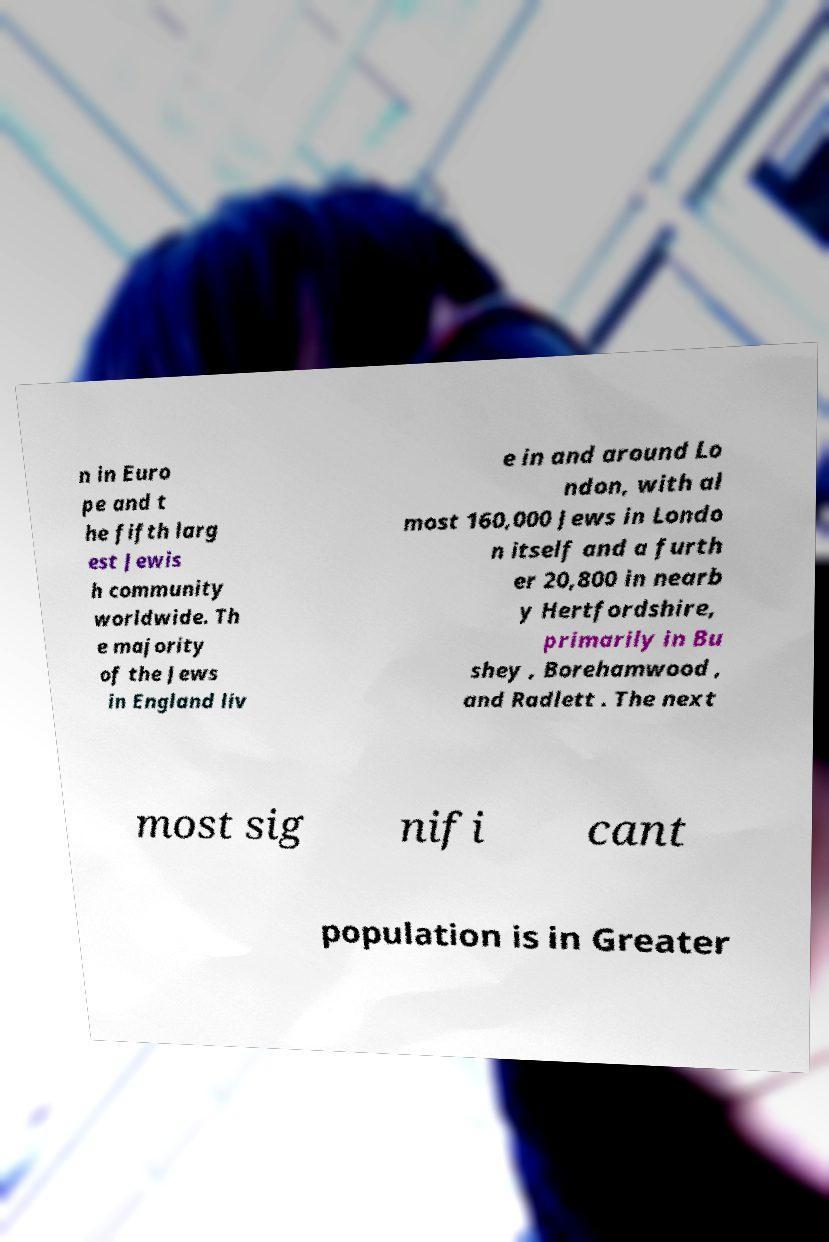Can you accurately transcribe the text from the provided image for me? n in Euro pe and t he fifth larg est Jewis h community worldwide. Th e majority of the Jews in England liv e in and around Lo ndon, with al most 160,000 Jews in Londo n itself and a furth er 20,800 in nearb y Hertfordshire, primarily in Bu shey , Borehamwood , and Radlett . The next most sig nifi cant population is in Greater 